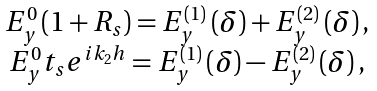<formula> <loc_0><loc_0><loc_500><loc_500>\begin{array} { c } E _ { y } ^ { 0 } \left ( 1 + R _ { s } \right ) = E _ { y } ^ { ( 1 ) } \left ( \delta \right ) + E _ { y } ^ { ( 2 ) } \left ( \delta \right ) , \\ E _ { y } ^ { 0 } t _ { s } e ^ { i k _ { 2 } h } = E _ { y } ^ { ( 1 ) } \left ( \delta \right ) - E _ { y } ^ { ( 2 ) } \left ( \delta \right ) , \end{array}</formula> 